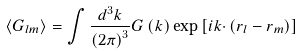<formula> <loc_0><loc_0><loc_500><loc_500>\left \langle G _ { l m } \right \rangle = \int \frac { d ^ { 3 } k } { \left ( 2 \pi \right ) ^ { 3 } } G \left ( { k } \right ) \exp \left [ i { k \cdot } \left ( { r } _ { l } - { r } _ { m } \right ) \right ]</formula> 